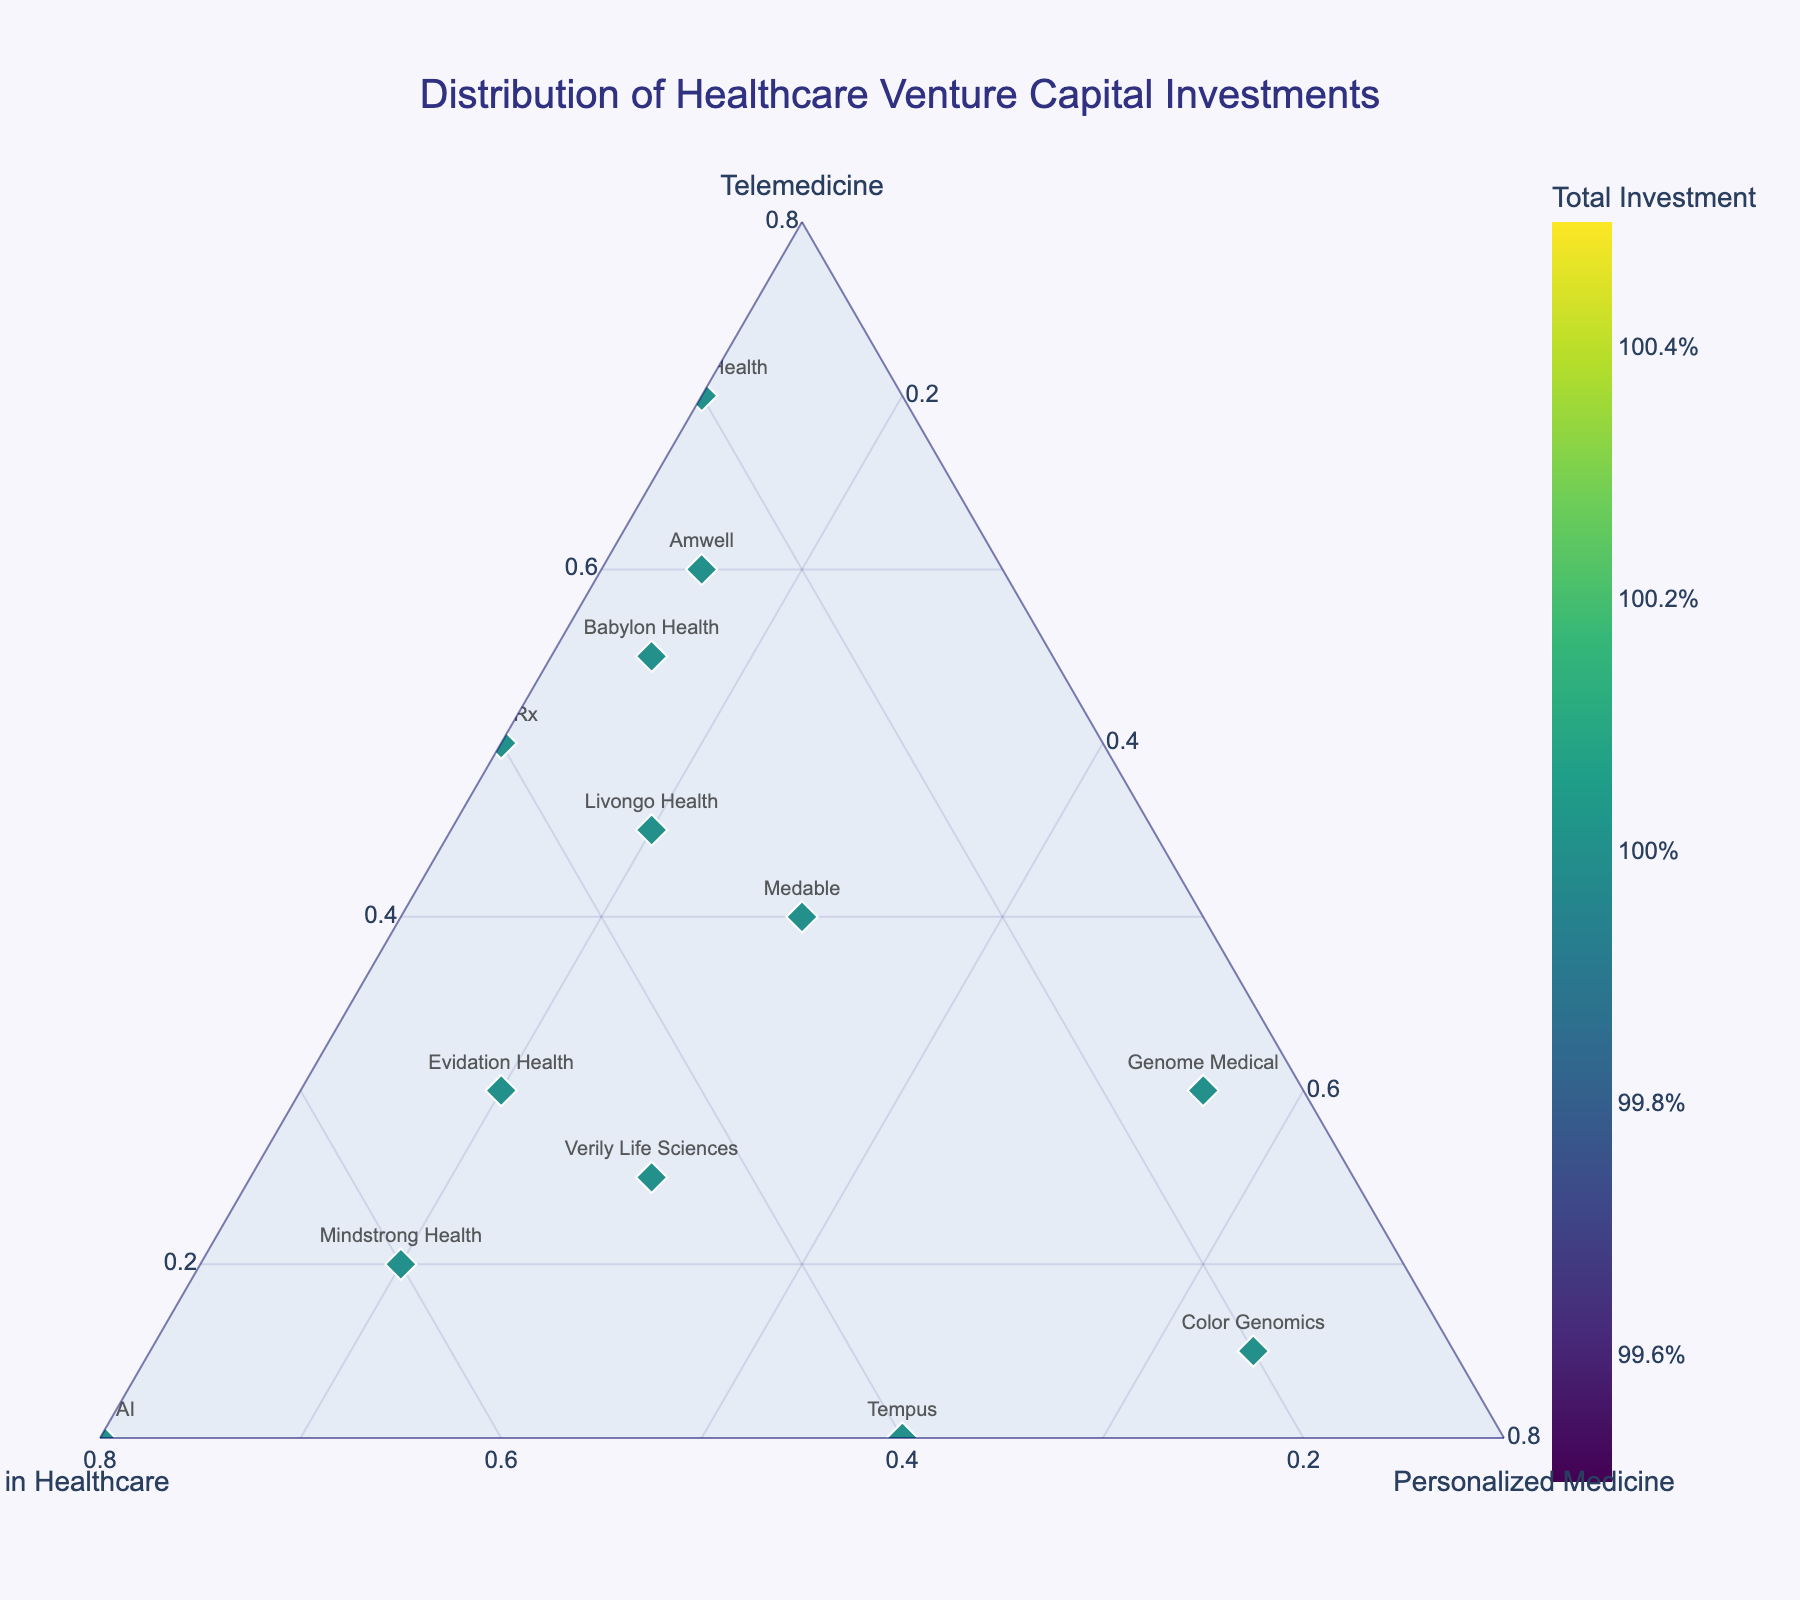What does the title of the plot indicate? The title of the plot is "Distribution of Healthcare Venture Capital Investments," which suggests that the plot shows how venture capital investments are distributed among three areas in the healthcare sector: Telemedicine, AI in Healthcare, and Personalized Medicine.
Answer: Distribution of Healthcare Venture Capital Investments How many companies are represented in the plot? By counting the data points or markers on the ternary plot, one can see that there are 15 companies represented.
Answer: 15 Which company has the highest investment in AI in Healthcare? By looking at the data points positioned highest along the AI in Healthcare axis, "Olive AI" stands out as having the highest investment in this area.
Answer: Olive AI What is the range of the total investments across these companies? The total investments for each company can be visually assessed by the color intensity of the markers, which range from lighter to darker shades. The data shows the total investment ranges between 45% (23andMe) to 110% (Tempus).
Answer: 45% to 110% Which company has the most balanced investment across the three categories? A balanced investment would be indicated by a point near the center of the ternary plot. "Medable" appears to be the company with the most balanced distribution.
Answer: Medable Are there any companies that have a higher investment in Telemedicine compared to other areas? Points near the Telemedicine axis represent higher investment in this area. "Teladoc Health" has the highest investment in Telemedicine at 70%, followed by "Amwell" at 60%.
Answer: Teladoc Health, Amwell What is the combined investment percentage of AI in Healthcare and Personalized Medicine for Livongo Health? To compute the combined investment, add the percentages of AI in Healthcare (35%) and Personalized Medicine (20%) for Livongo Health, resulting in a total of 55%.
Answer: 55% Which two companies have the closest investment distributions? By visually comparing the positions of the markers, "Amwell" and "Babylon Health" have similar positions, indicating close investment distributions in Telemedicine, AI in Healthcare, and Personalized Medicine.
Answer: Amwell and Babylon Health What is the investment distribution for Genome Medical? By looking at the plot, Genome Medical has investments of 30% in Telemedicine, 15% in AI in Healthcare, and 55% in Personalized Medicine.
Answer: 30% Telemedicine, 15% AI in Healthcare, 55% Personalized Medicine Which axis has the least variation among the points, indicating somewhat consistent investment? By visually assessing the spread of points along each axis, the Personalized Medicine axis appears to have the least variation, as most points are distributed more evenly along this axis compared to others.
Answer: Personalized Medicine axis 